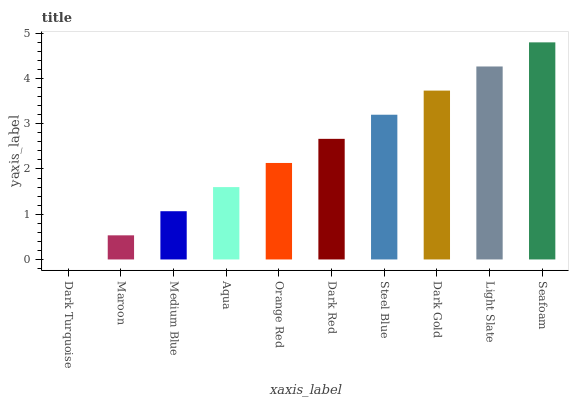Is Dark Turquoise the minimum?
Answer yes or no. Yes. Is Seafoam the maximum?
Answer yes or no. Yes. Is Maroon the minimum?
Answer yes or no. No. Is Maroon the maximum?
Answer yes or no. No. Is Maroon greater than Dark Turquoise?
Answer yes or no. Yes. Is Dark Turquoise less than Maroon?
Answer yes or no. Yes. Is Dark Turquoise greater than Maroon?
Answer yes or no. No. Is Maroon less than Dark Turquoise?
Answer yes or no. No. Is Dark Red the high median?
Answer yes or no. Yes. Is Orange Red the low median?
Answer yes or no. Yes. Is Dark Turquoise the high median?
Answer yes or no. No. Is Dark Gold the low median?
Answer yes or no. No. 